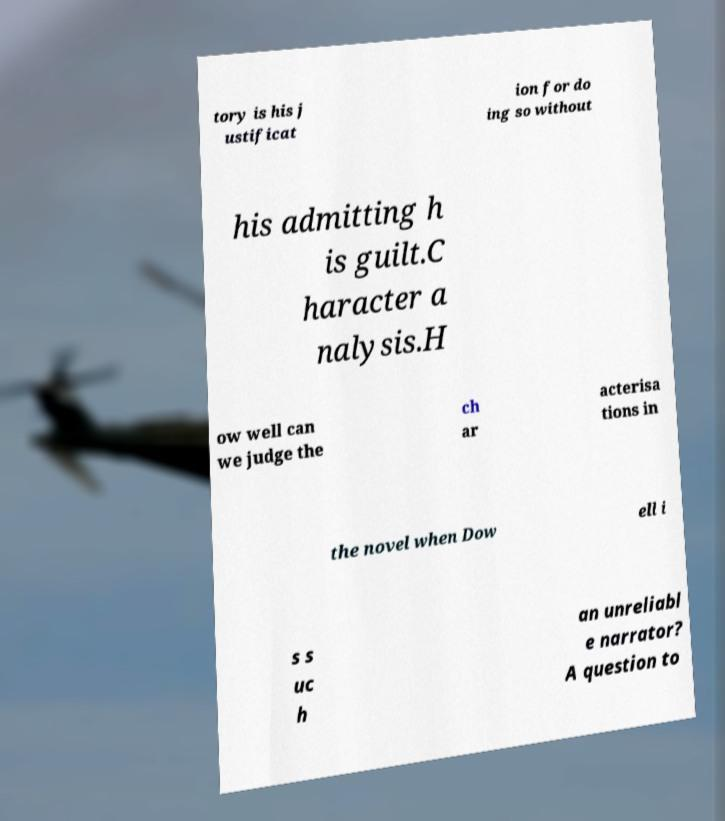For documentation purposes, I need the text within this image transcribed. Could you provide that? tory is his j ustificat ion for do ing so without his admitting h is guilt.C haracter a nalysis.H ow well can we judge the ch ar acterisa tions in the novel when Dow ell i s s uc h an unreliabl e narrator? A question to 